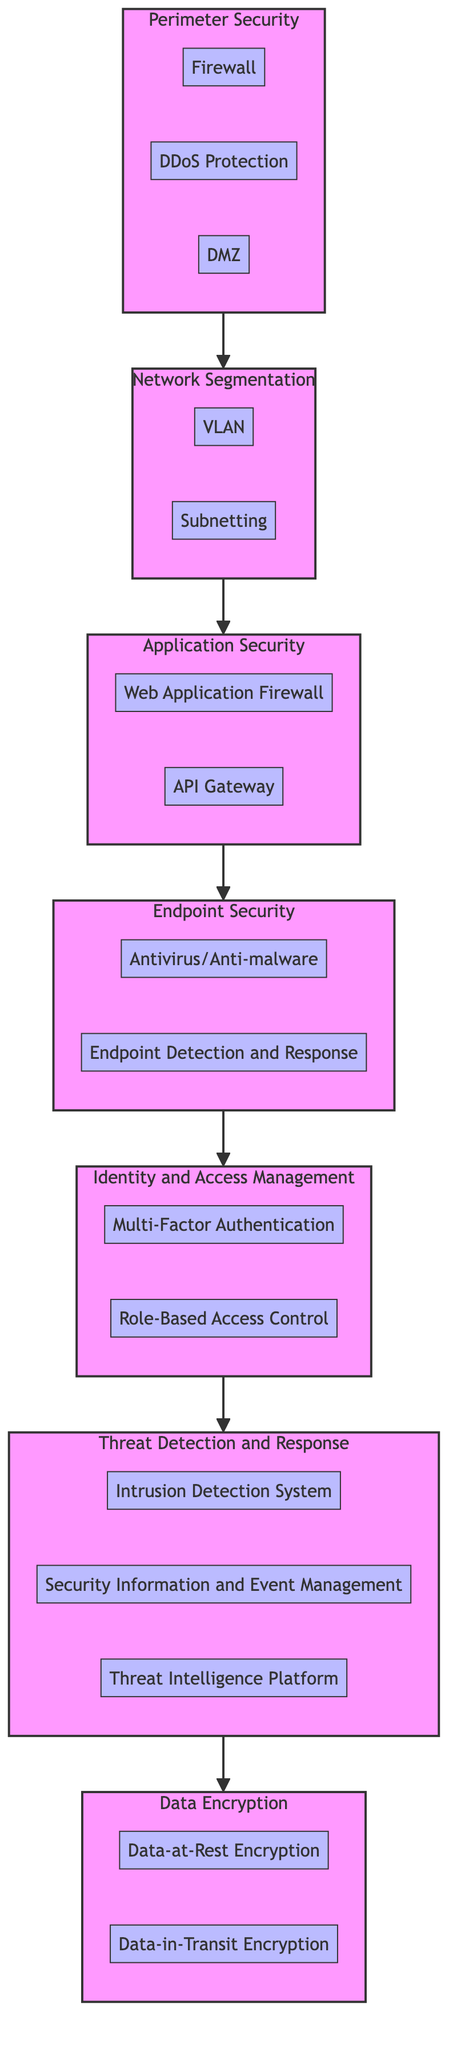What are the components of the Perimeter Security layer? The Perimeter Security layer has three components: Firewall, DDoS Protection, and DMZ.
Answer: Firewall, DDoS Protection, DMZ How many layers are depicted in the diagram? The diagram shows a total of seven layers: Perimeter Security, Network Segmentation, Application Security, Endpoint Security, Identity and Access Management, Threat Detection and Response, and Data Encryption.
Answer: Seven Which layer comes before the Application Security layer? The layer that comes before Application Security, as per the flow chart, is Network Segmentation.
Answer: Network Segmentation What is the relationship between Threat Detection and Response and Data Encryption layers? Threat Detection and Response directly feeds into Data Encryption, indicating that security measures taken from threat detection will lead to actions taken on data encryption.
Answer: Direct relationship What component is found in the Identity and Access Management layer that enhances security? The Identity and Access Management layer includes the Multi-Factor Authentication component, which enhances security by requiring multiple forms of verification.
Answer: Multi-Factor Authentication Name one component in the Endpoint Security layer that addresses malware. The Endpoint Security layer contains Antivirus/Anti-malware, which is specifically designed to detect and neutralize malware threats.
Answer: Antivirus/Anti-malware Which layer includes the Threat Intelligence Platform component? The Threat Intelligence Platform is found within the Threat Detection and Response layer of the diagram.
Answer: Threat Detection and Response How many components are there in the Application Security layer? The Application Security layer consists of two components: Web Application Firewall and API Gateway.
Answer: Two What type of encryption protects data stored on disk? Data-at-Rest Encryption is the type of encryption that protects data stored on disk.
Answer: Data-at-Rest Encryption 